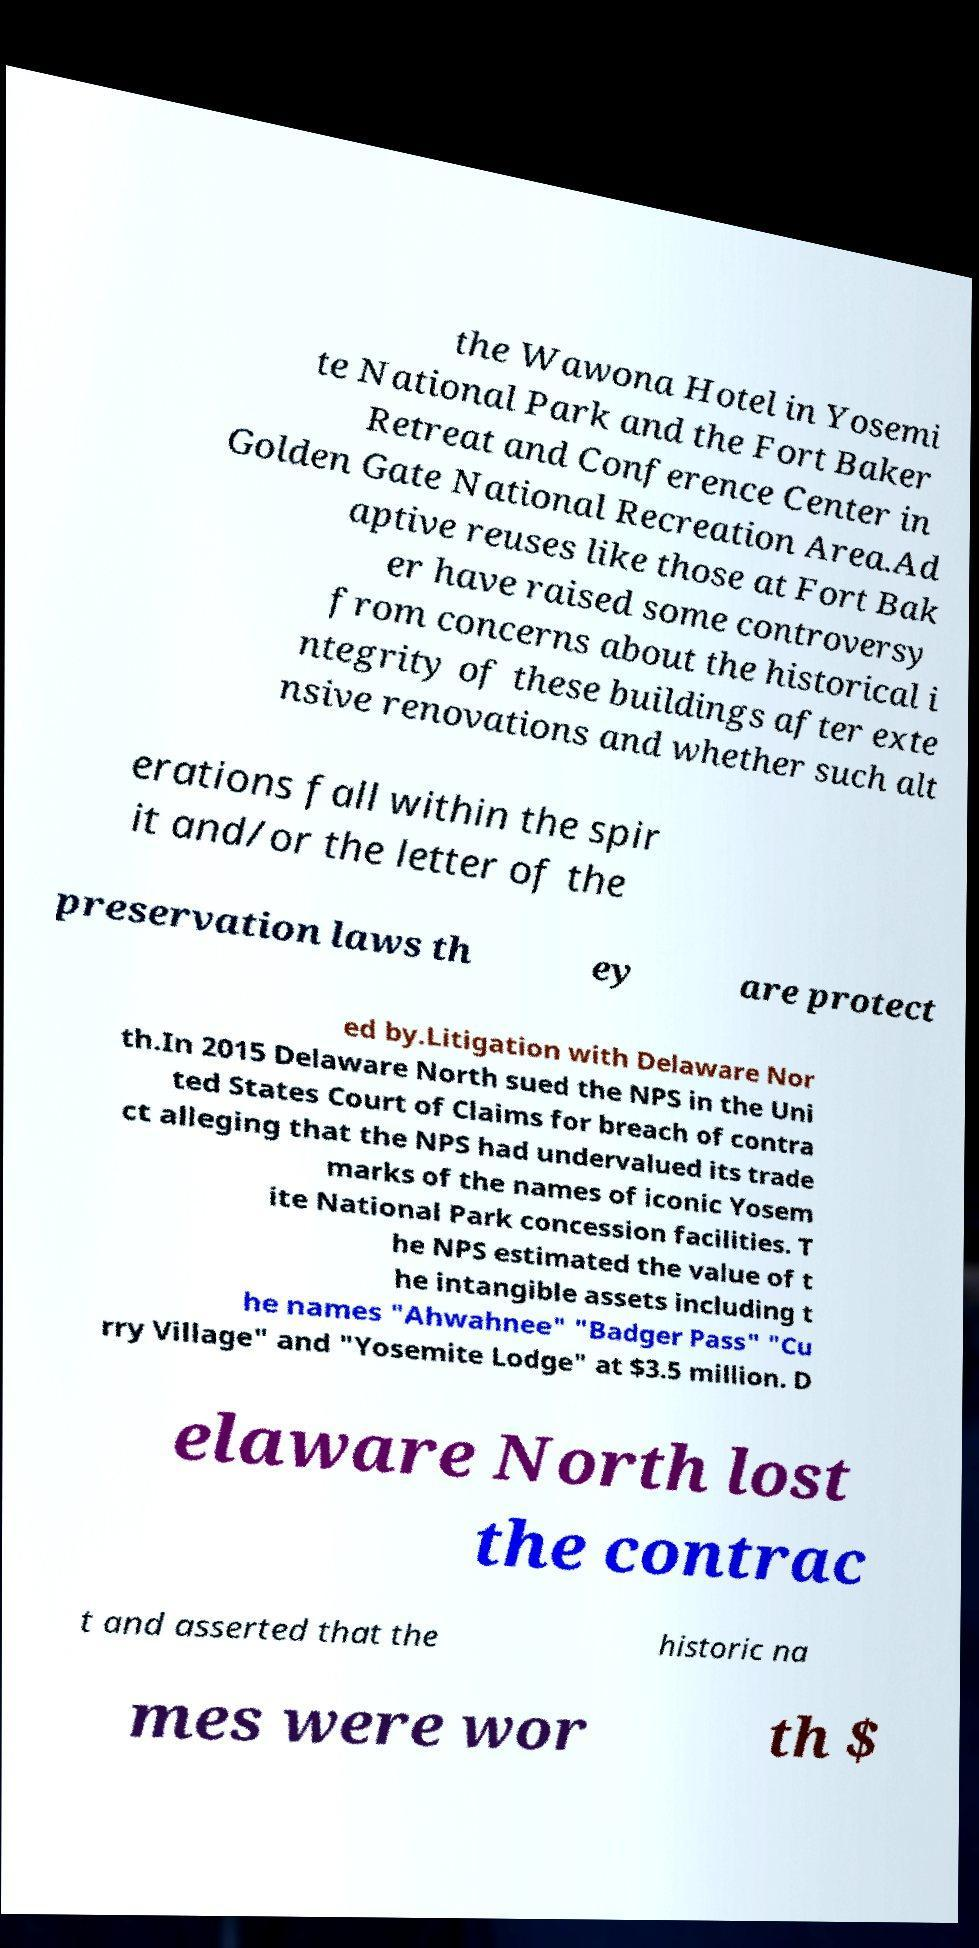Can you read and provide the text displayed in the image?This photo seems to have some interesting text. Can you extract and type it out for me? the Wawona Hotel in Yosemi te National Park and the Fort Baker Retreat and Conference Center in Golden Gate National Recreation Area.Ad aptive reuses like those at Fort Bak er have raised some controversy from concerns about the historical i ntegrity of these buildings after exte nsive renovations and whether such alt erations fall within the spir it and/or the letter of the preservation laws th ey are protect ed by.Litigation with Delaware Nor th.In 2015 Delaware North sued the NPS in the Uni ted States Court of Claims for breach of contra ct alleging that the NPS had undervalued its trade marks of the names of iconic Yosem ite National Park concession facilities. T he NPS estimated the value of t he intangible assets including t he names "Ahwahnee" "Badger Pass" "Cu rry Village" and "Yosemite Lodge" at $3.5 million. D elaware North lost the contrac t and asserted that the historic na mes were wor th $ 